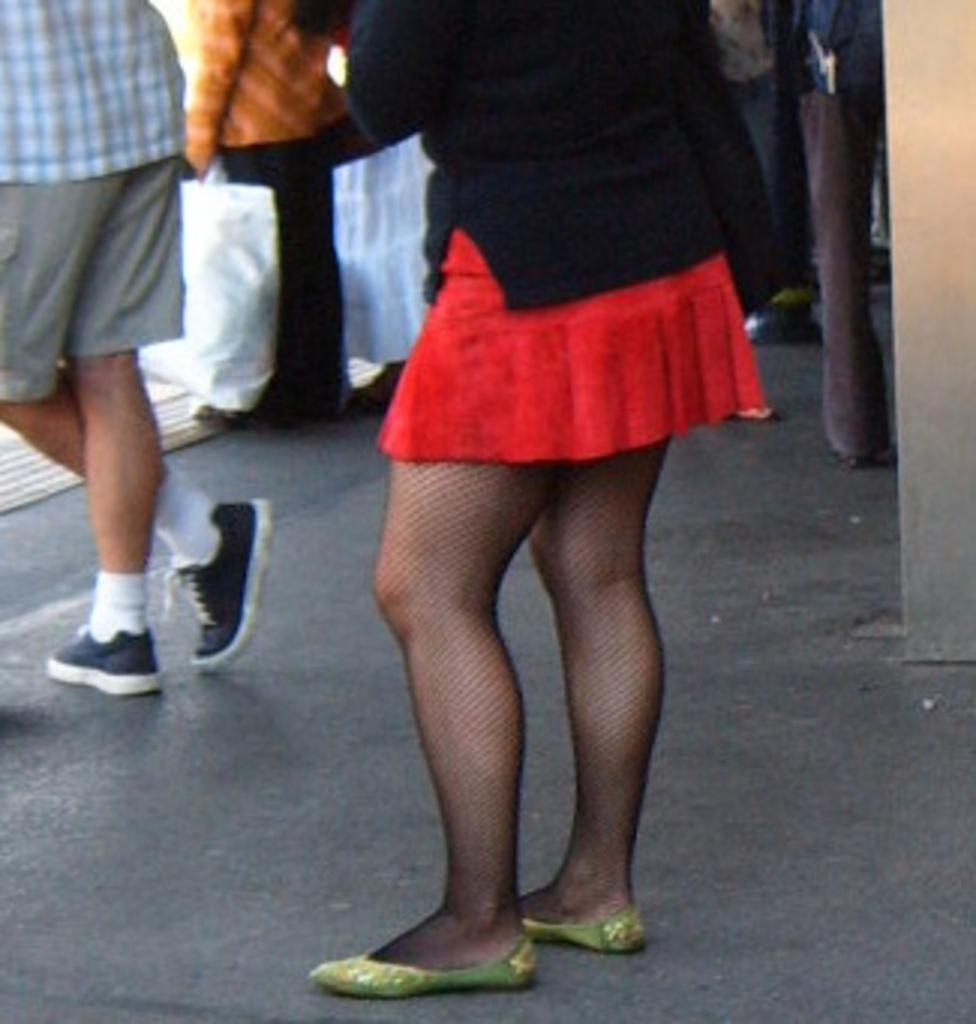What is the main subject of the image? The main subject of the image is a group of people. What are the people in the image doing? The people are standing. How can we differentiate the people in the image? The people are wearing different color dresses. Can you identify any specific object that one person is holding? Yes, one person is holding a bag. How many legs does the beetle have in the image? There is no beetle present in the image. What type of camp can be seen in the background of the image? There is no camp visible in the image; it features a group of people standing and wearing different color dresses. 